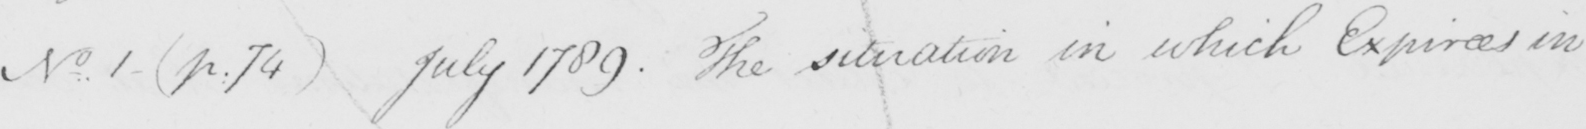Please transcribe the handwritten text in this image. No . 1  ( p . 74 )  July 1789 . The situation in which Expirees in 